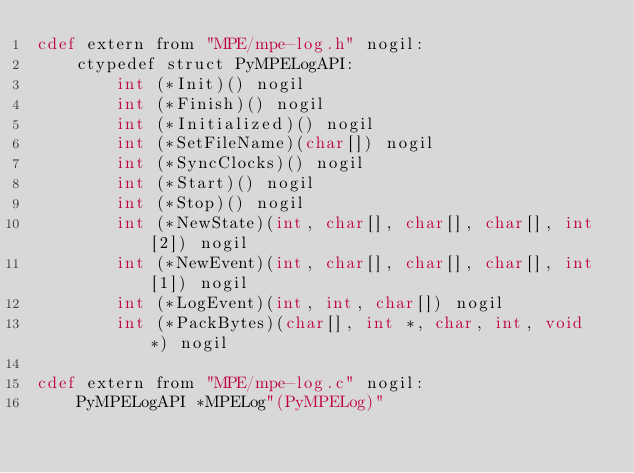Convert code to text. <code><loc_0><loc_0><loc_500><loc_500><_Cython_>cdef extern from "MPE/mpe-log.h" nogil:
    ctypedef struct PyMPELogAPI:
        int (*Init)() nogil
        int (*Finish)() nogil
        int (*Initialized)() nogil
        int (*SetFileName)(char[]) nogil
        int (*SyncClocks)() nogil
        int (*Start)() nogil
        int (*Stop)() nogil
        int (*NewState)(int, char[], char[], char[], int[2]) nogil
        int (*NewEvent)(int, char[], char[], char[], int[1]) nogil
        int (*LogEvent)(int, int, char[]) nogil
        int (*PackBytes)(char[], int *, char, int, void *) nogil

cdef extern from "MPE/mpe-log.c" nogil:
    PyMPELogAPI *MPELog"(PyMPELog)"
</code> 